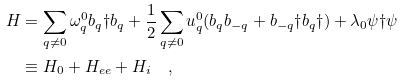Convert formula to latex. <formula><loc_0><loc_0><loc_500><loc_500>H & = \sum _ { q \neq 0 } \omega _ { q } ^ { 0 } b _ { q } \dag b _ { q } + \frac { 1 } { 2 } \sum _ { q \neq 0 } u _ { q } ^ { 0 } ( b _ { q } b _ { - q } + b _ { - q } \dag b _ { q } \dag ) + \lambda _ { 0 } \psi \dag \psi \\ & \equiv H _ { 0 } + H _ { e e } + H _ { i } \quad ,</formula> 